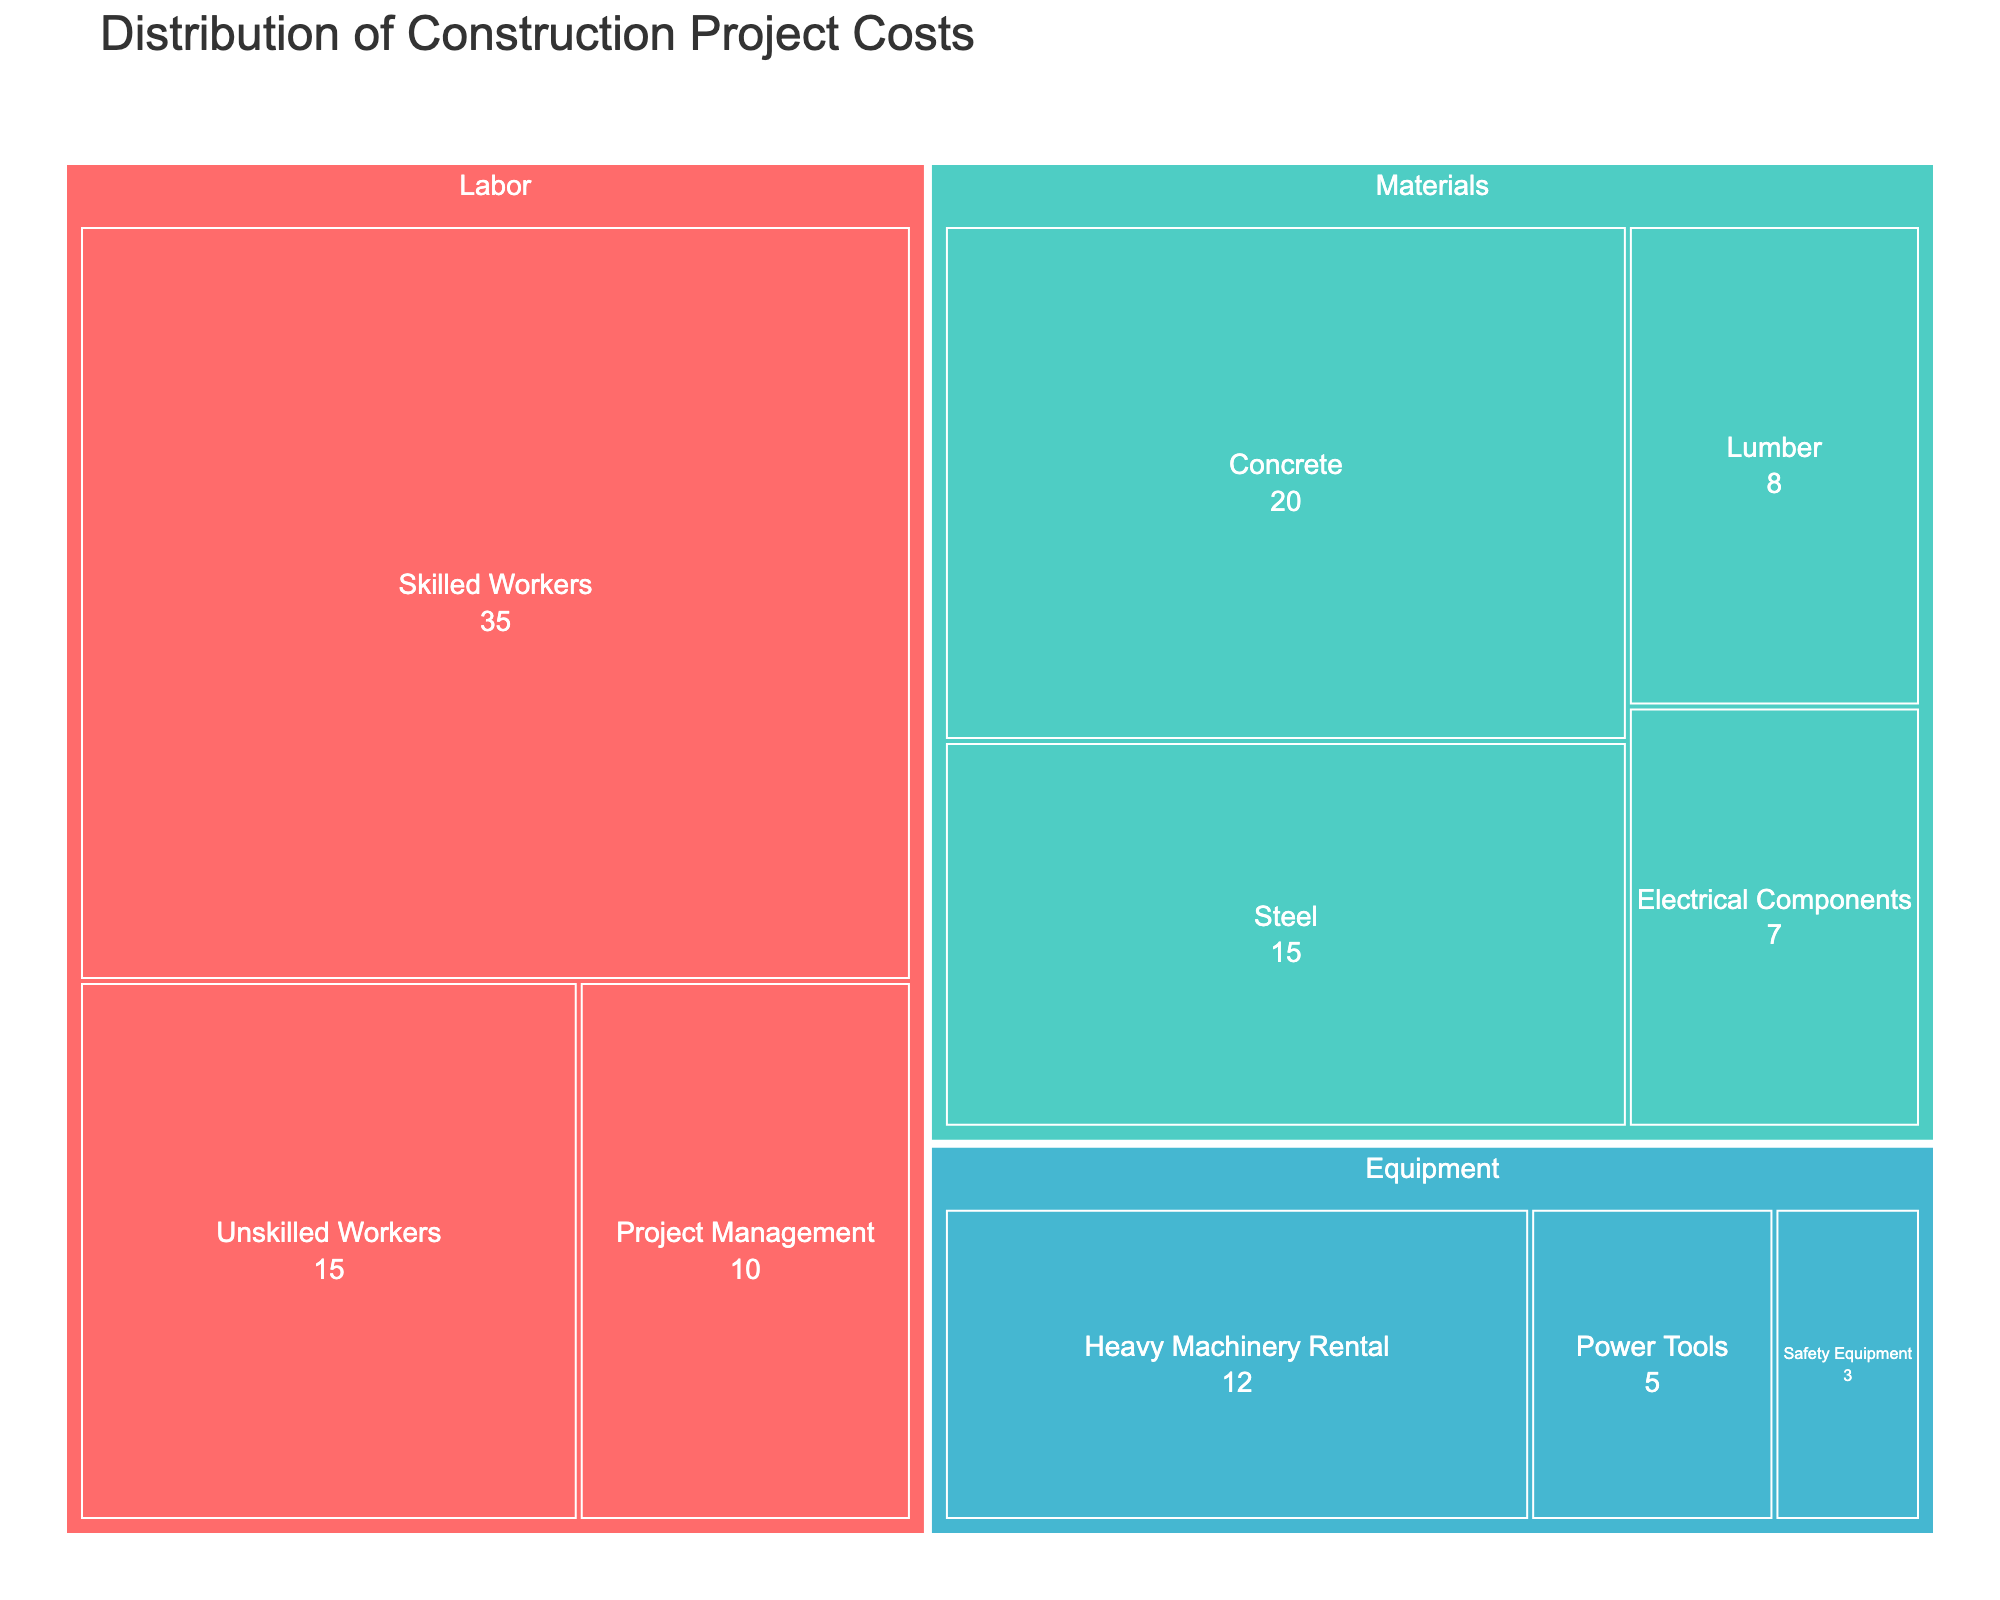What's the total cost of labor? To find the total cost of labor, add the costs of Skilled Workers, Unskilled Workers, and Project Management. These costs are 35, 15, and 10 respectively, so the total is 35 + 15 + 10 = 60.
Answer: 60 Which subcategory has the highest cost? Examine the sizes of all subcategories in the treemap. Skilled Workers has the largest block, indicating the highest cost at 35.
Answer: Skilled Workers What's the cost difference between Concrete and Steel in the Materials category? The cost of Concrete is 20 and the cost of Steel is 15. Subtract the cost of Steel from the cost of Concrete to find the difference: 20 - 15 = 5.
Answer: 5 How does the total cost of Materials compare to Equipment? First, sum the costs in each category. Materials: 20 (Concrete) + 15 (Steel) + 8 (Lumber) + 7 (Electrical Components) = 50. Equipment: 12 (Heavy Machinery Rental) + 5 (Power Tools) + 3 (Safety Equipment) = 20. Materials cost 50, and Equipment costs 20. Compare these values to note that Materials cost more than Equipment: 50 > 20.
Answer: Materials cost more What's the second most expensive subcategory in the Labor category? In the Labor category, Skilled Workers cost 35, Unskilled Workers cost 15, and Project Management costs 10. The second most expensive subcategory is Unskilled Workers with a cost of 15.
Answer: Unskilled Workers What proportion of the total project cost is spent on Equipment? First, calculate the total project cost: Labor (60) + Materials (50) + Equipment (20) = 130. Then, find the proportion for Equipment: Equipment cost (20) / Total cost (130) = 20 / 130 ≈ 0.1538, or about 15%.
Answer: 15% Which category has the least total cost, and what is that cost? Sum the costs in each category. Labor costs 60, Materials cost 50, and Equipment costs 20. The category with the least total cost is Equipment, with a cost of 20.
Answer: Equipment, 20 What is the average cost of the subcategories under Materials? Calculate the total cost for Materials (50) and divide by the number of subcategories (4): 50 / 4 = 12.5.
Answer: 12.5 If the cost of Skilled Workers was reduced by 5, what would be the new total cost for the Labor category? Current cost of Skilled Workers is 35. Reducing by 5 gives 35 - 5 = 30. New total for Labor: 30 (Skilled Workers) + 15 (Unskilled Workers) + 10 (Project Management) = 55.
Answer: 55 How many subcategories have a cost greater than or equal to 10? Subcategories with costs 35 (Skilled Workers), 15 (Unskilled Workers), 10 (Project Management), 20 (Concrete), 15 (Steel), and 12 (Heavy Machinery Rental) meet this criterion. There are 6 subcategories.
Answer: 6 